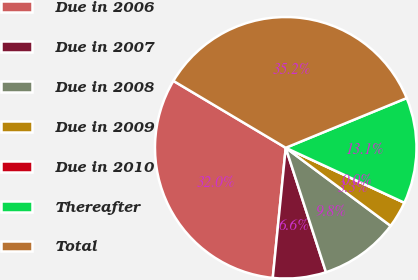<chart> <loc_0><loc_0><loc_500><loc_500><pie_chart><fcel>Due in 2006<fcel>Due in 2007<fcel>Due in 2008<fcel>Due in 2009<fcel>Due in 2010<fcel>Thereafter<fcel>Total<nl><fcel>31.97%<fcel>6.56%<fcel>9.84%<fcel>3.28%<fcel>0.0%<fcel>13.11%<fcel>35.25%<nl></chart> 